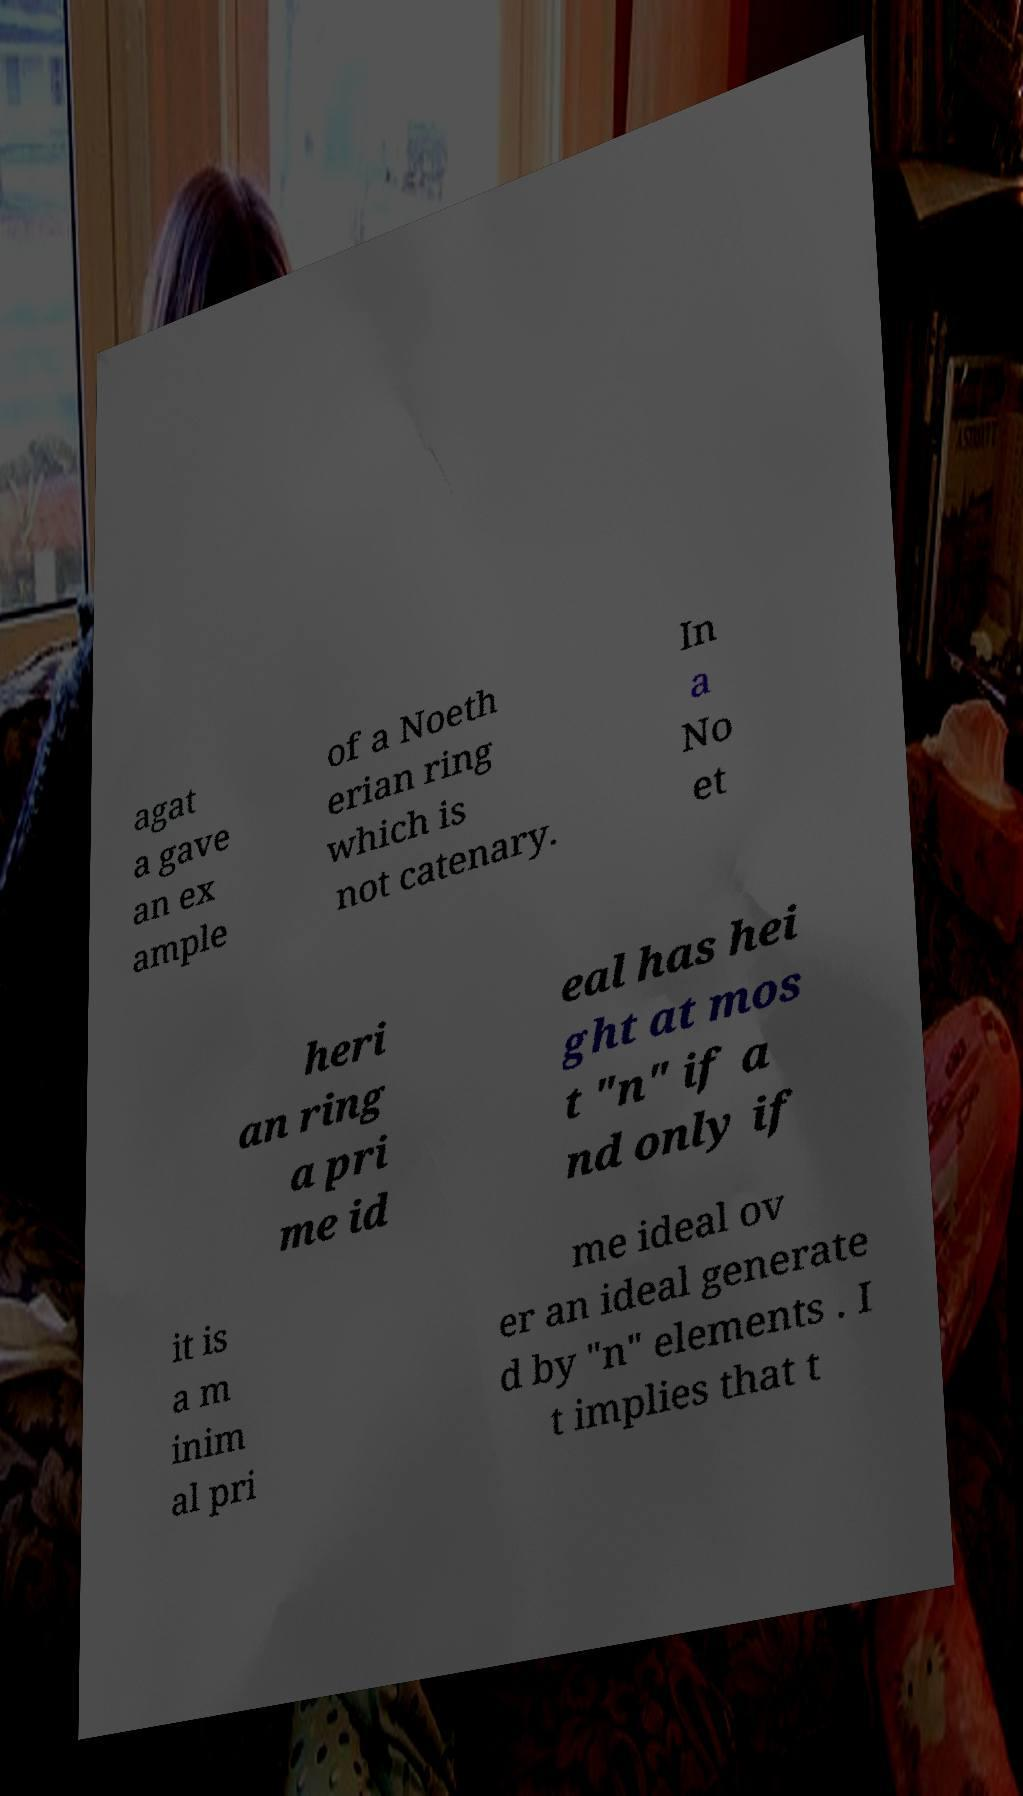Could you extract and type out the text from this image? agat a gave an ex ample of a Noeth erian ring which is not catenary. In a No et heri an ring a pri me id eal has hei ght at mos t "n" if a nd only if it is a m inim al pri me ideal ov er an ideal generate d by "n" elements . I t implies that t 